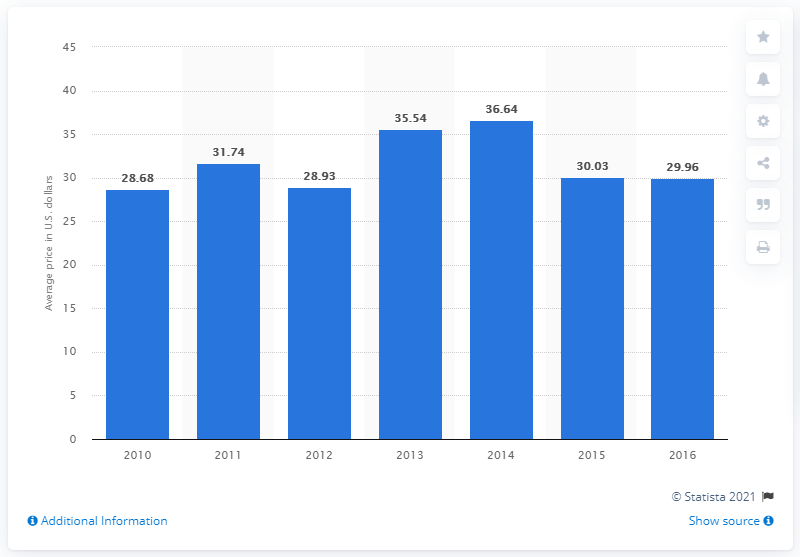Point out several critical features in this image. In 2014, the average cost of a soak-off gel application in nail salons was $36.64. 